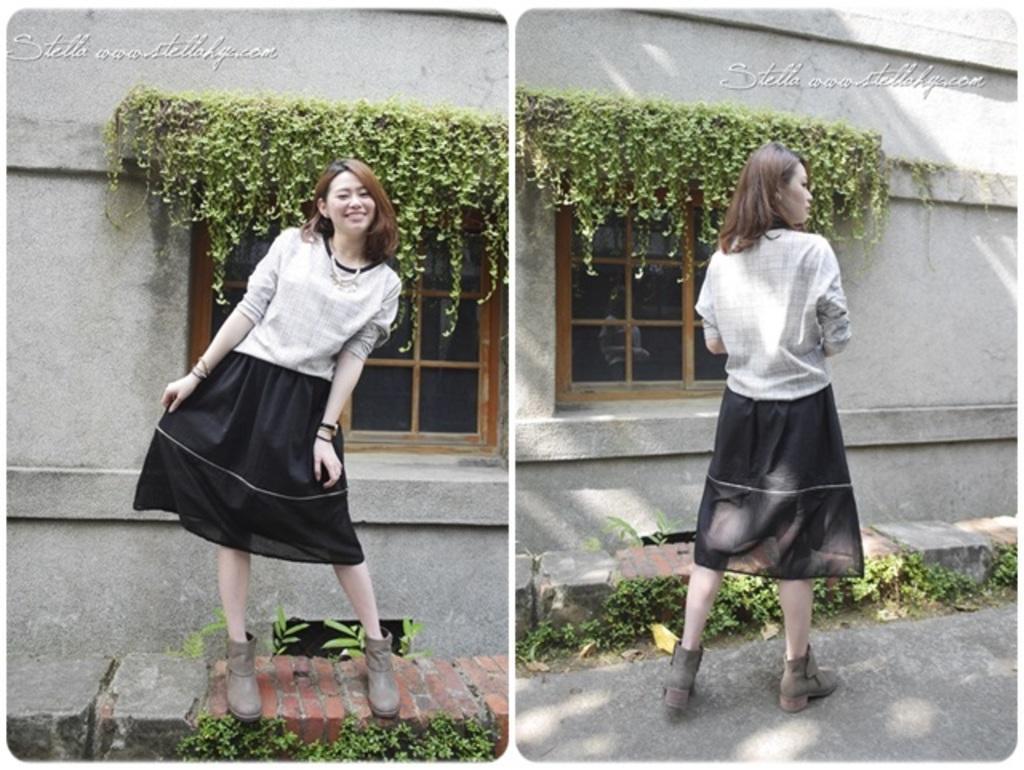Please provide a concise description of this image. In this image we can see a collage pictures, in those pictures there is a lady, windows, plants, walls, rocks, also we can see some texts on both the pictures. 